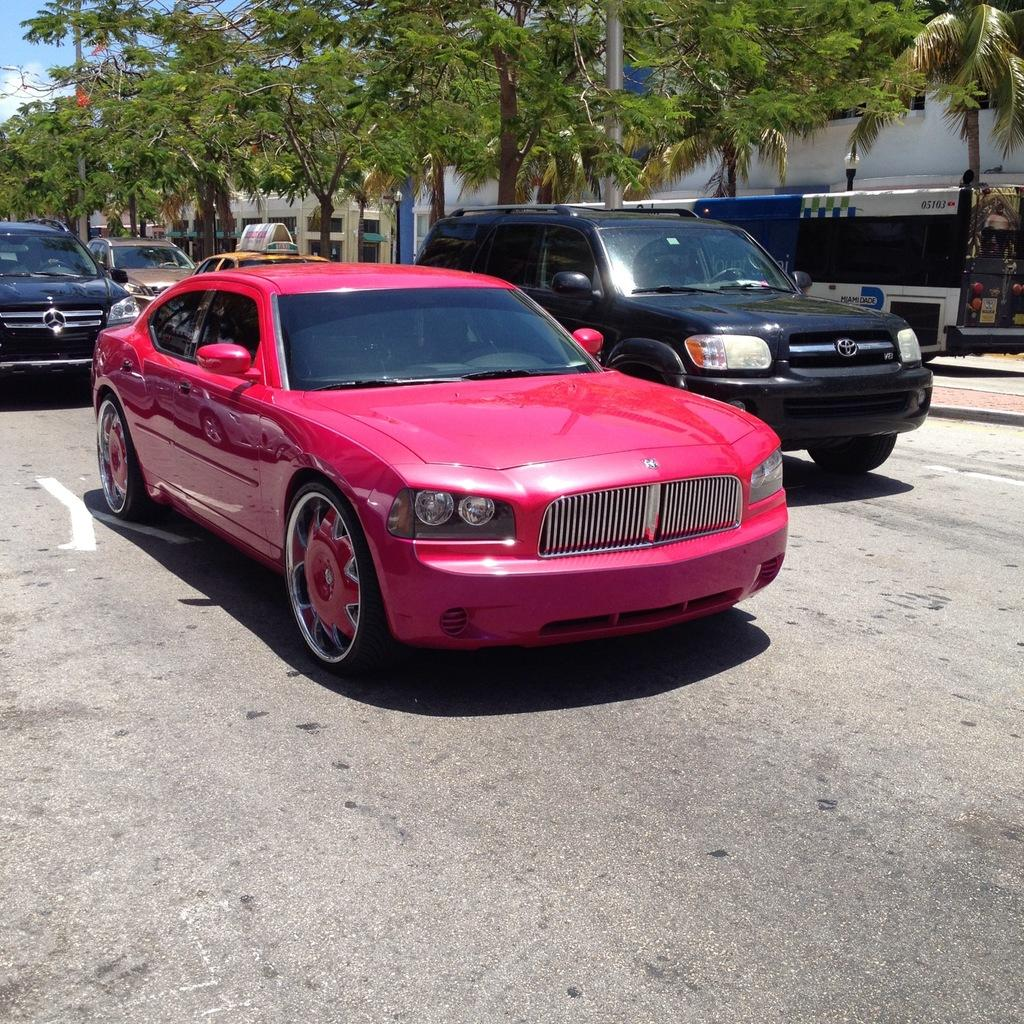What can be seen on the road in the image? There are vehicles on the road in the image. What objects in the image emit light? There are lights in the image. What structures are present in the image that support the lights? There are poles in the image. What type of vegetation is visible in the image? There are trees in the image. What type of man-made structures can be seen in the background of the image? There are buildings in the background of the image. What part of the natural environment is visible in the background of the image? The sky is visible in the background of the image. Where is the rake being used in the image? There is no rake present in the image. What type of toad can be seen hopping on the vehicles in the image? There are no toads present in the image, and the vehicles are stationary. 